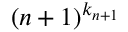<formula> <loc_0><loc_0><loc_500><loc_500>( { n + 1 } ) ^ { k _ { n + 1 } }</formula> 